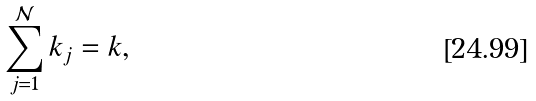<formula> <loc_0><loc_0><loc_500><loc_500>\sum ^ { \mathcal { N } } _ { j = 1 } k _ { j } = k ,</formula> 